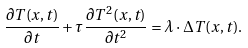Convert formula to latex. <formula><loc_0><loc_0><loc_500><loc_500>\frac { \partial T ( x , t ) } { \partial t } + \tau \frac { { \partial { T ^ { 2 } } ( x , t ) } } { { \partial { t ^ { 2 } } } } = \lambda \cdot \Delta T ( x , t ) .</formula> 